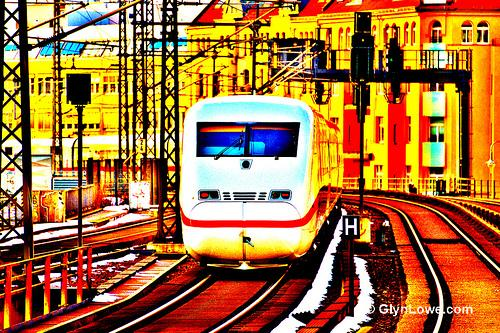In a short sentence, mention the central object and what it is doing in the image. The white and yellow train is stationed on the track next to buildings and signs. Mention the main object in the image and the colors that appear on it. The foremost object is a train with white, yellow, and red colors displayed. Provide a brief description of the primary focus in the image. A white and yellow train is on the track with red lights and a red stripe on the front, surrounded by buildings and signs. Identify the main object in the picture and mention its most noticeable feature. The principal object is a train that is white and yellow with red lights at the front. Describe the key subject of the image and its surroundings in one sentence. The image features a white and yellow train with red accents, located on a track with nearby buildings and signs. State the color and a distinct characteristic of the main subject in the picture. The train is white and yellow, featuring red lights and a red stripe on the front. Describe the primary object and its surroundings in the image. A white and yellow train stands on the track with a red stripe and red lights on the front, alongside buildings, signs, and a green traffic light. Give a brief visual summary of the main subject and its environment in the image. The image showcases a white and yellow train on a track, with red lights and stripes, surrounded by buildings and signs. In a concise manner, describe the central element of the image and its position. A white and yellow train with red lights is positioned on the track near buildings. Identify the most striking element in the picture and state its color and purpose. The most notable element is a white and yellow train with red lights meant for visibility. 